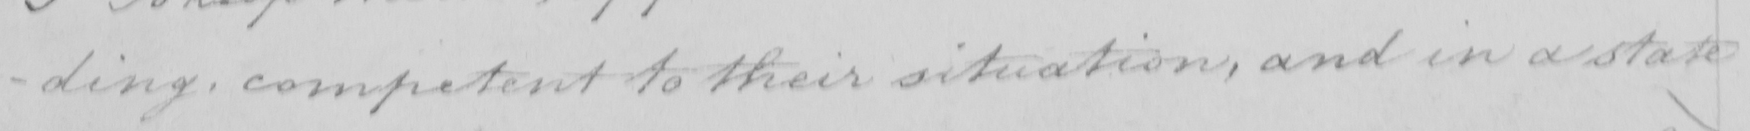Please provide the text content of this handwritten line. -ding competent to their situation , and in a state 